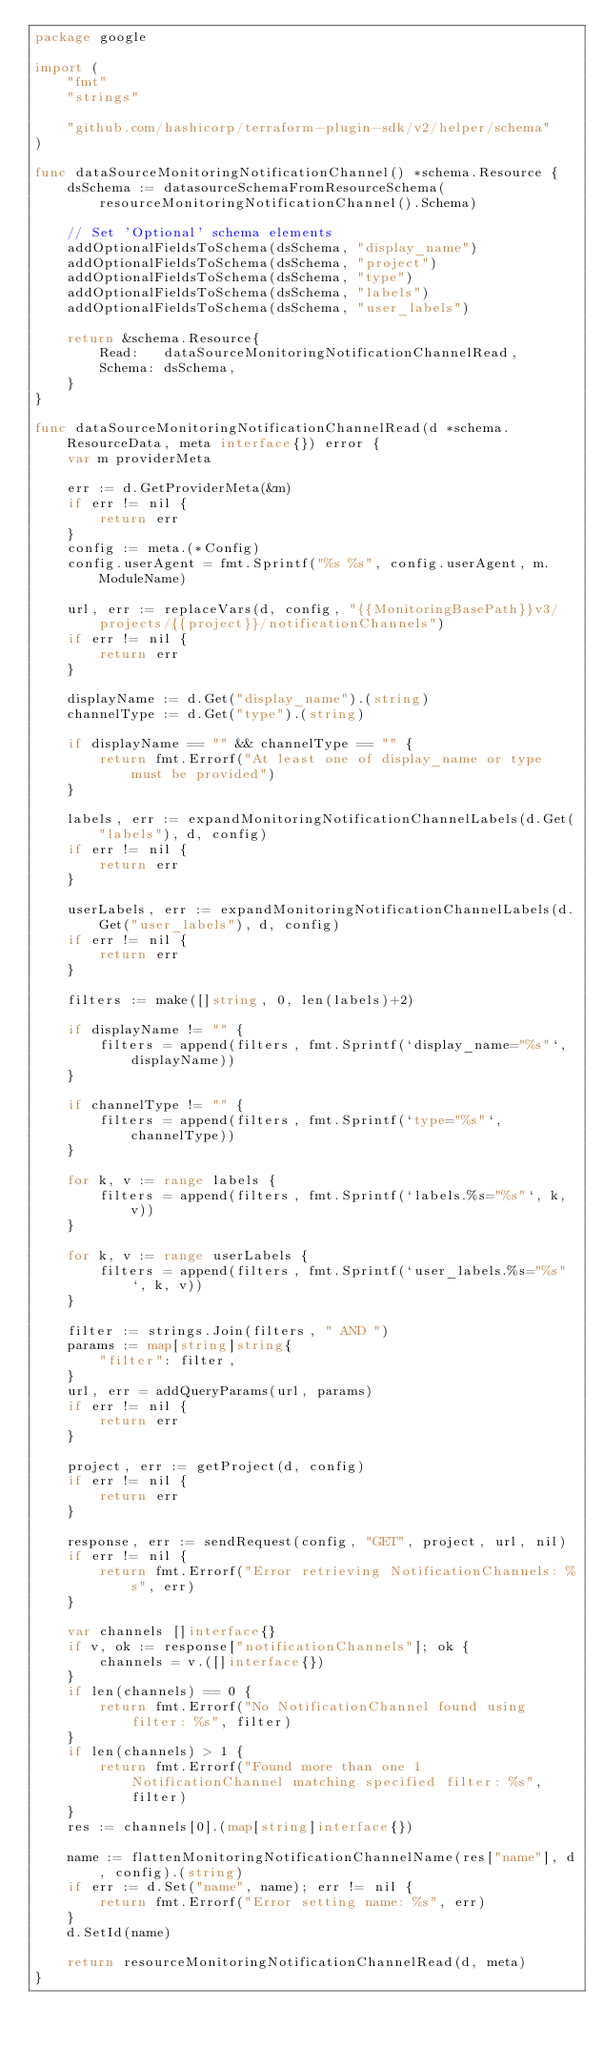<code> <loc_0><loc_0><loc_500><loc_500><_Go_>package google

import (
	"fmt"
	"strings"

	"github.com/hashicorp/terraform-plugin-sdk/v2/helper/schema"
)

func dataSourceMonitoringNotificationChannel() *schema.Resource {
	dsSchema := datasourceSchemaFromResourceSchema(resourceMonitoringNotificationChannel().Schema)

	// Set 'Optional' schema elements
	addOptionalFieldsToSchema(dsSchema, "display_name")
	addOptionalFieldsToSchema(dsSchema, "project")
	addOptionalFieldsToSchema(dsSchema, "type")
	addOptionalFieldsToSchema(dsSchema, "labels")
	addOptionalFieldsToSchema(dsSchema, "user_labels")

	return &schema.Resource{
		Read:   dataSourceMonitoringNotificationChannelRead,
		Schema: dsSchema,
	}
}

func dataSourceMonitoringNotificationChannelRead(d *schema.ResourceData, meta interface{}) error {
	var m providerMeta

	err := d.GetProviderMeta(&m)
	if err != nil {
		return err
	}
	config := meta.(*Config)
	config.userAgent = fmt.Sprintf("%s %s", config.userAgent, m.ModuleName)

	url, err := replaceVars(d, config, "{{MonitoringBasePath}}v3/projects/{{project}}/notificationChannels")
	if err != nil {
		return err
	}

	displayName := d.Get("display_name").(string)
	channelType := d.Get("type").(string)

	if displayName == "" && channelType == "" {
		return fmt.Errorf("At least one of display_name or type must be provided")
	}

	labels, err := expandMonitoringNotificationChannelLabels(d.Get("labels"), d, config)
	if err != nil {
		return err
	}

	userLabels, err := expandMonitoringNotificationChannelLabels(d.Get("user_labels"), d, config)
	if err != nil {
		return err
	}

	filters := make([]string, 0, len(labels)+2)

	if displayName != "" {
		filters = append(filters, fmt.Sprintf(`display_name="%s"`, displayName))
	}

	if channelType != "" {
		filters = append(filters, fmt.Sprintf(`type="%s"`, channelType))
	}

	for k, v := range labels {
		filters = append(filters, fmt.Sprintf(`labels.%s="%s"`, k, v))
	}

	for k, v := range userLabels {
		filters = append(filters, fmt.Sprintf(`user_labels.%s="%s"`, k, v))
	}

	filter := strings.Join(filters, " AND ")
	params := map[string]string{
		"filter": filter,
	}
	url, err = addQueryParams(url, params)
	if err != nil {
		return err
	}

	project, err := getProject(d, config)
	if err != nil {
		return err
	}

	response, err := sendRequest(config, "GET", project, url, nil)
	if err != nil {
		return fmt.Errorf("Error retrieving NotificationChannels: %s", err)
	}

	var channels []interface{}
	if v, ok := response["notificationChannels"]; ok {
		channels = v.([]interface{})
	}
	if len(channels) == 0 {
		return fmt.Errorf("No NotificationChannel found using filter: %s", filter)
	}
	if len(channels) > 1 {
		return fmt.Errorf("Found more than one 1 NotificationChannel matching specified filter: %s", filter)
	}
	res := channels[0].(map[string]interface{})

	name := flattenMonitoringNotificationChannelName(res["name"], d, config).(string)
	if err := d.Set("name", name); err != nil {
		return fmt.Errorf("Error setting name: %s", err)
	}
	d.SetId(name)

	return resourceMonitoringNotificationChannelRead(d, meta)
}
</code> 